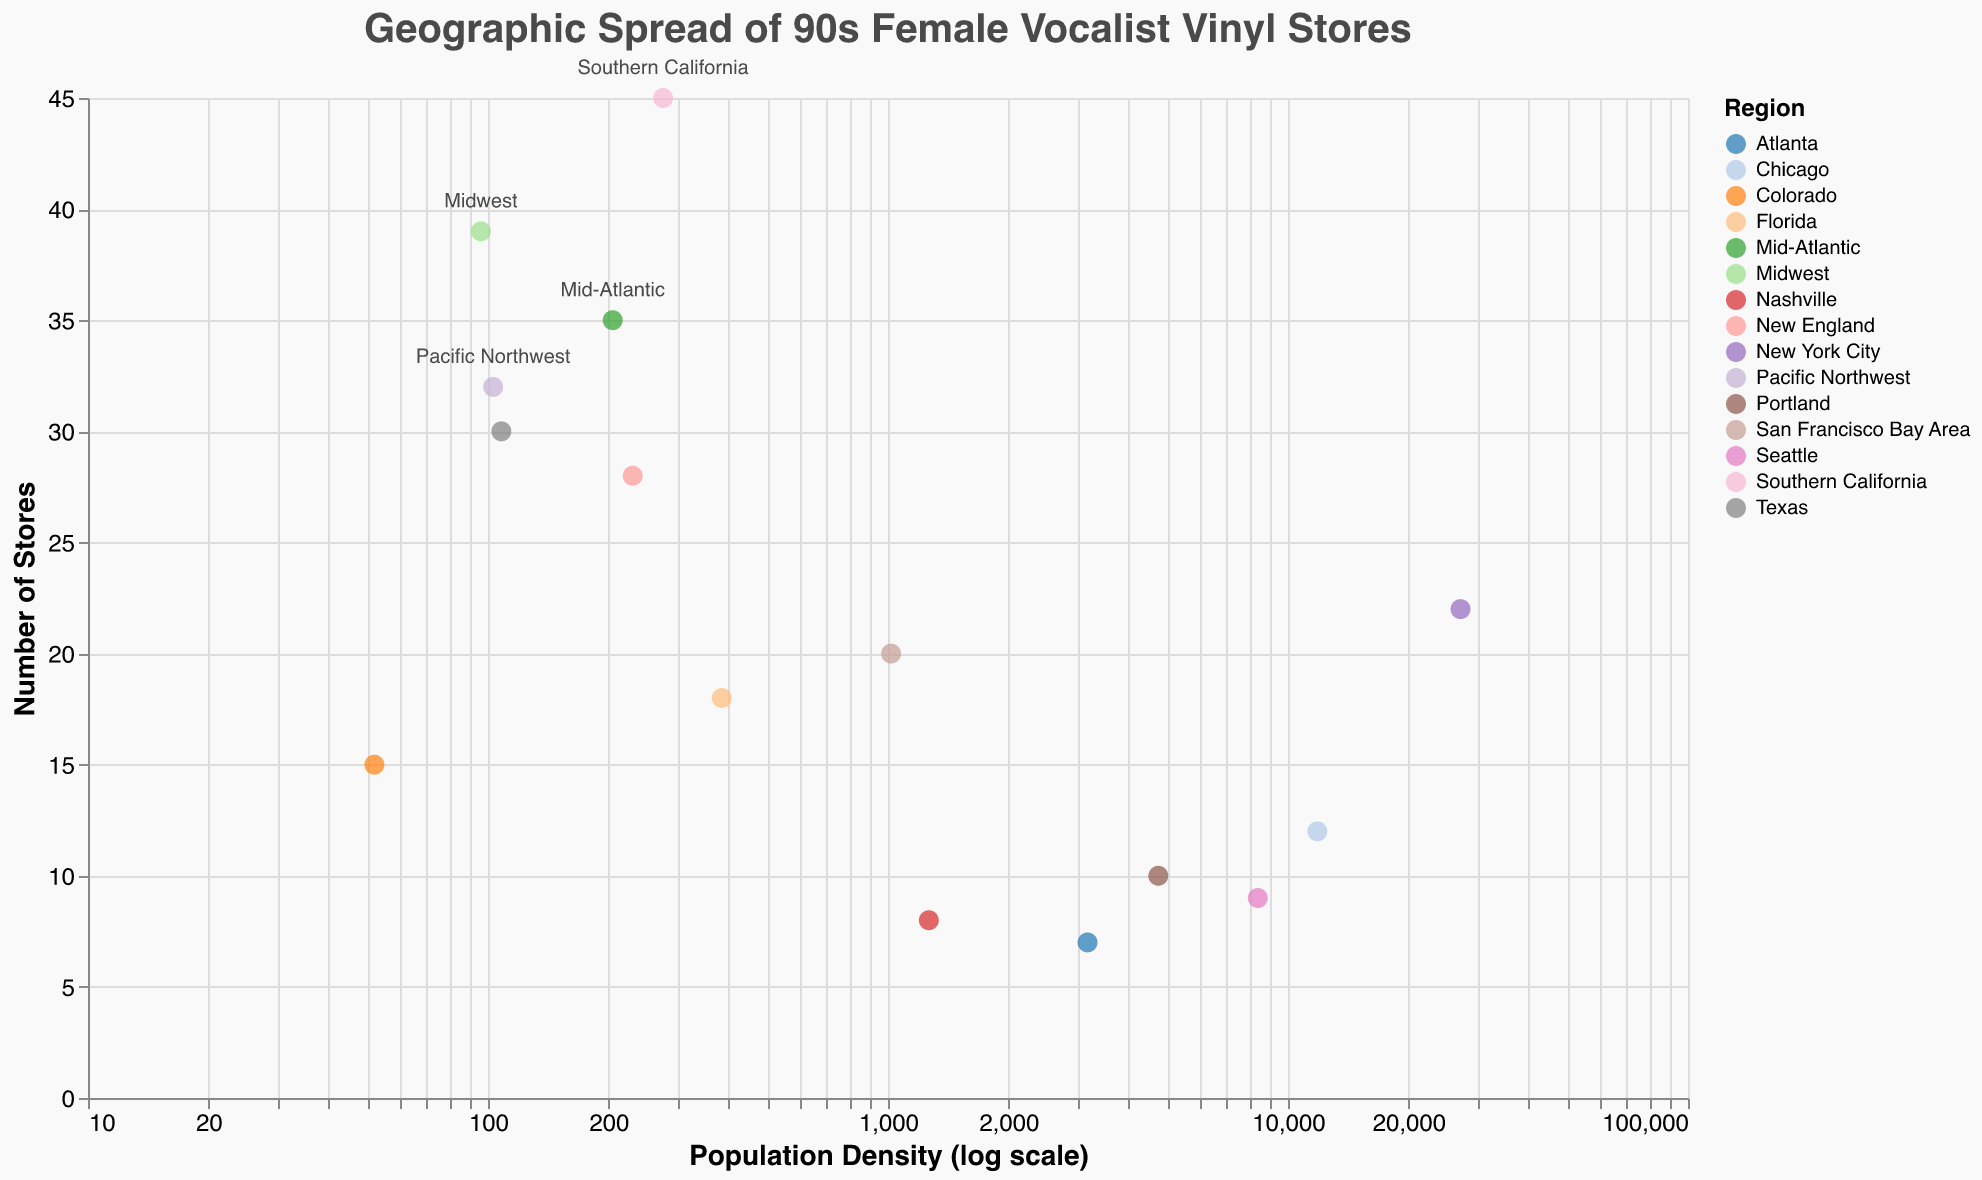Which region has the highest number of vinyl stores? For this, you need to look at the y-axis which represents the number of stores and find the highest point. Southern California has the highest number at 45 stores.
Answer: Southern California What is the notable store in New York City? The tooltip information includes notable stores for each region. New York City's notable store is Rough Trade NYC.
Answer: Rough Trade NYC Which region has the lowest population density? Looking at the x-axis on a log scale, Colorado has the lowest population density at 52.
Answer: Colorado How many more stores does Southern California have compared to Chicago? Southern California has 45 stores, and Chicago has 12 stores. Subtracting 12 from 45 gives 33 more stores.
Answer: 33 What is the relationship between population density and the number of stores for the Mid-Atlantic region? The Mid-Atlantic region has a population density of 205 and 35 stores. There isn't a clear direct relationship visible between population density and the number of stores for this specific region alone from the plot.
Answer: 205 population density, 35 stores Which region with a notable store has the highest population density? The region with the notable store and the highest population density is New York City with Rough Trade NYC, with a density of 27000.
Answer: New York City Does Florida have more or fewer vinyl stores than Colorado? Comparing the store counts, Florida has 18 stores and Colorado has 15 stores, so Florida has more.
Answer: More Which regions have their names displayed on the plot? The labels are shown for regions with more than 30 stores: Southern California, Midwest, and Mid-Atlantic.
Answer: Southern California, Midwest, Mid-Atlantic What is the average number of stores in regions with a population density greater than 1000? The regions with population density over 1000 are Atlanta, San Francisco Bay Area, Chicago, New York City, Portland, Seattle, and Nashville. Their store counts are 7, 20, 12, 22, 10, 9, and 8, respectively. Summing these gives 88, and dividing by 7 regions gives an average of 12.57.
Answer: 12.57 Which region has more stores, Texas or New England? Texas has 30 stores, and New England has 28 stores. Texas has more stores.
Answer: Texas 